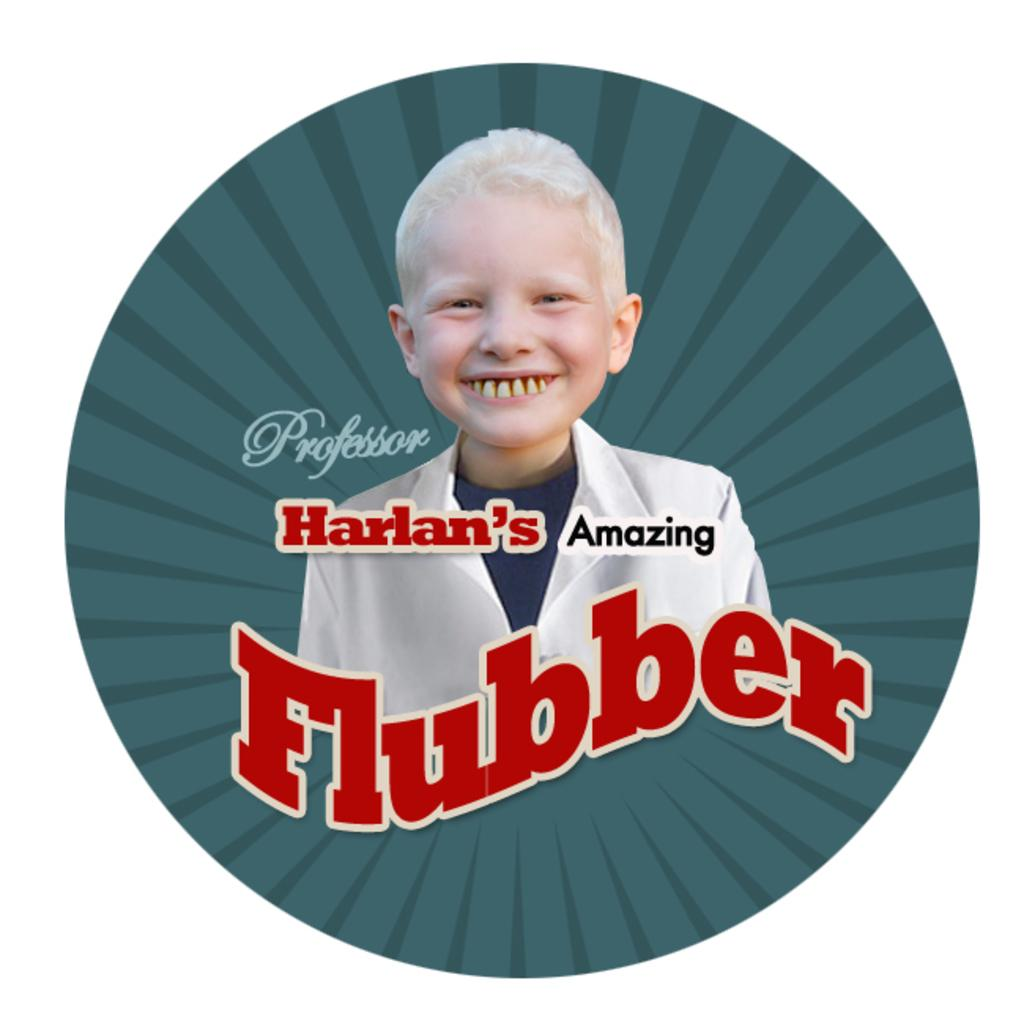<image>
Provide a brief description of the given image. An ad for Professor Harlan's Amazing Flubber has a child in the image. 